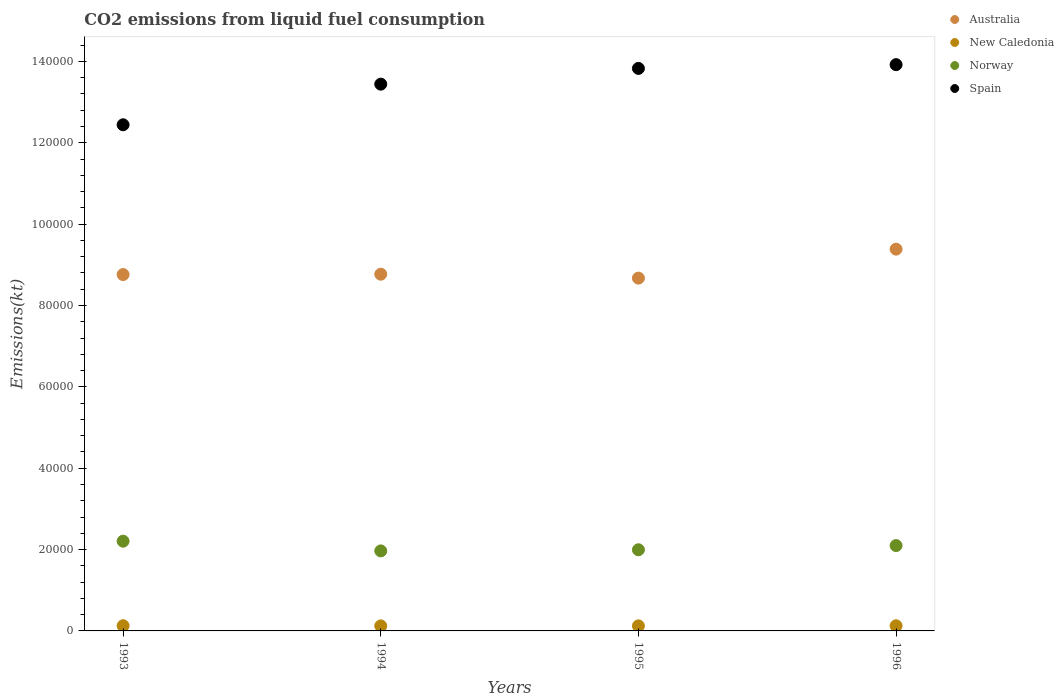Is the number of dotlines equal to the number of legend labels?
Your answer should be very brief. Yes. What is the amount of CO2 emitted in New Caledonia in 1994?
Make the answer very short. 1239.45. Across all years, what is the maximum amount of CO2 emitted in Australia?
Ensure brevity in your answer.  9.38e+04. Across all years, what is the minimum amount of CO2 emitted in New Caledonia?
Your answer should be very brief. 1239.45. In which year was the amount of CO2 emitted in Spain minimum?
Keep it short and to the point. 1993. What is the total amount of CO2 emitted in Spain in the graph?
Provide a short and direct response. 5.36e+05. What is the difference between the amount of CO2 emitted in New Caledonia in 1994 and that in 1996?
Provide a succinct answer. -29.34. What is the difference between the amount of CO2 emitted in Spain in 1995 and the amount of CO2 emitted in Norway in 1996?
Offer a terse response. 1.17e+05. What is the average amount of CO2 emitted in Spain per year?
Offer a very short reply. 1.34e+05. In the year 1993, what is the difference between the amount of CO2 emitted in Spain and amount of CO2 emitted in Australia?
Offer a terse response. 3.68e+04. What is the ratio of the amount of CO2 emitted in Spain in 1993 to that in 1996?
Make the answer very short. 0.89. Is the difference between the amount of CO2 emitted in Spain in 1993 and 1995 greater than the difference between the amount of CO2 emitted in Australia in 1993 and 1995?
Provide a succinct answer. No. What is the difference between the highest and the second highest amount of CO2 emitted in New Caledonia?
Give a very brief answer. 7.33. What is the difference between the highest and the lowest amount of CO2 emitted in Spain?
Your answer should be compact. 1.48e+04. In how many years, is the amount of CO2 emitted in Norway greater than the average amount of CO2 emitted in Norway taken over all years?
Make the answer very short. 2. Is it the case that in every year, the sum of the amount of CO2 emitted in Norway and amount of CO2 emitted in New Caledonia  is greater than the sum of amount of CO2 emitted in Australia and amount of CO2 emitted in Spain?
Keep it short and to the point. No. Is it the case that in every year, the sum of the amount of CO2 emitted in Norway and amount of CO2 emitted in New Caledonia  is greater than the amount of CO2 emitted in Australia?
Your answer should be compact. No. Is the amount of CO2 emitted in New Caledonia strictly greater than the amount of CO2 emitted in Norway over the years?
Keep it short and to the point. No. How many dotlines are there?
Offer a very short reply. 4. How many years are there in the graph?
Keep it short and to the point. 4. What is the difference between two consecutive major ticks on the Y-axis?
Keep it short and to the point. 2.00e+04. Does the graph contain any zero values?
Give a very brief answer. No. Does the graph contain grids?
Provide a succinct answer. No. How many legend labels are there?
Your answer should be compact. 4. What is the title of the graph?
Your response must be concise. CO2 emissions from liquid fuel consumption. Does "Aruba" appear as one of the legend labels in the graph?
Ensure brevity in your answer.  No. What is the label or title of the Y-axis?
Give a very brief answer. Emissions(kt). What is the Emissions(kt) of Australia in 1993?
Your answer should be very brief. 8.76e+04. What is the Emissions(kt) of New Caledonia in 1993?
Offer a very short reply. 1276.12. What is the Emissions(kt) of Norway in 1993?
Keep it short and to the point. 2.21e+04. What is the Emissions(kt) of Spain in 1993?
Your response must be concise. 1.24e+05. What is the Emissions(kt) of Australia in 1994?
Your answer should be compact. 8.77e+04. What is the Emissions(kt) of New Caledonia in 1994?
Offer a very short reply. 1239.45. What is the Emissions(kt) in Norway in 1994?
Make the answer very short. 1.97e+04. What is the Emissions(kt) in Spain in 1994?
Provide a succinct answer. 1.34e+05. What is the Emissions(kt) in Australia in 1995?
Provide a short and direct response. 8.67e+04. What is the Emissions(kt) in New Caledonia in 1995?
Give a very brief answer. 1239.45. What is the Emissions(kt) of Norway in 1995?
Keep it short and to the point. 1.99e+04. What is the Emissions(kt) of Spain in 1995?
Your answer should be compact. 1.38e+05. What is the Emissions(kt) in Australia in 1996?
Your answer should be compact. 9.38e+04. What is the Emissions(kt) of New Caledonia in 1996?
Provide a succinct answer. 1268.78. What is the Emissions(kt) of Norway in 1996?
Give a very brief answer. 2.10e+04. What is the Emissions(kt) in Spain in 1996?
Your answer should be very brief. 1.39e+05. Across all years, what is the maximum Emissions(kt) of Australia?
Give a very brief answer. 9.38e+04. Across all years, what is the maximum Emissions(kt) in New Caledonia?
Ensure brevity in your answer.  1276.12. Across all years, what is the maximum Emissions(kt) in Norway?
Your response must be concise. 2.21e+04. Across all years, what is the maximum Emissions(kt) of Spain?
Offer a very short reply. 1.39e+05. Across all years, what is the minimum Emissions(kt) of Australia?
Provide a short and direct response. 8.67e+04. Across all years, what is the minimum Emissions(kt) in New Caledonia?
Keep it short and to the point. 1239.45. Across all years, what is the minimum Emissions(kt) of Norway?
Your answer should be very brief. 1.97e+04. Across all years, what is the minimum Emissions(kt) in Spain?
Your response must be concise. 1.24e+05. What is the total Emissions(kt) in Australia in the graph?
Offer a very short reply. 3.56e+05. What is the total Emissions(kt) in New Caledonia in the graph?
Provide a short and direct response. 5023.79. What is the total Emissions(kt) of Norway in the graph?
Provide a succinct answer. 8.27e+04. What is the total Emissions(kt) of Spain in the graph?
Provide a short and direct response. 5.36e+05. What is the difference between the Emissions(kt) in Australia in 1993 and that in 1994?
Offer a very short reply. -91.67. What is the difference between the Emissions(kt) in New Caledonia in 1993 and that in 1994?
Offer a terse response. 36.67. What is the difference between the Emissions(kt) of Norway in 1993 and that in 1994?
Give a very brief answer. 2390.88. What is the difference between the Emissions(kt) in Spain in 1993 and that in 1994?
Offer a very short reply. -9988.91. What is the difference between the Emissions(kt) in Australia in 1993 and that in 1995?
Your answer should be compact. 872.75. What is the difference between the Emissions(kt) in New Caledonia in 1993 and that in 1995?
Offer a terse response. 36.67. What is the difference between the Emissions(kt) in Norway in 1993 and that in 1995?
Keep it short and to the point. 2112.19. What is the difference between the Emissions(kt) in Spain in 1993 and that in 1995?
Give a very brief answer. -1.39e+04. What is the difference between the Emissions(kt) in Australia in 1993 and that in 1996?
Give a very brief answer. -6248.57. What is the difference between the Emissions(kt) of New Caledonia in 1993 and that in 1996?
Offer a very short reply. 7.33. What is the difference between the Emissions(kt) of Norway in 1993 and that in 1996?
Keep it short and to the point. 1081.77. What is the difference between the Emissions(kt) of Spain in 1993 and that in 1996?
Your response must be concise. -1.48e+04. What is the difference between the Emissions(kt) in Australia in 1994 and that in 1995?
Provide a succinct answer. 964.42. What is the difference between the Emissions(kt) in Norway in 1994 and that in 1995?
Provide a succinct answer. -278.69. What is the difference between the Emissions(kt) in Spain in 1994 and that in 1995?
Keep it short and to the point. -3868.68. What is the difference between the Emissions(kt) in Australia in 1994 and that in 1996?
Make the answer very short. -6156.89. What is the difference between the Emissions(kt) in New Caledonia in 1994 and that in 1996?
Provide a short and direct response. -29.34. What is the difference between the Emissions(kt) of Norway in 1994 and that in 1996?
Give a very brief answer. -1309.12. What is the difference between the Emissions(kt) of Spain in 1994 and that in 1996?
Keep it short and to the point. -4796.44. What is the difference between the Emissions(kt) in Australia in 1995 and that in 1996?
Offer a terse response. -7121.31. What is the difference between the Emissions(kt) in New Caledonia in 1995 and that in 1996?
Provide a short and direct response. -29.34. What is the difference between the Emissions(kt) of Norway in 1995 and that in 1996?
Provide a succinct answer. -1030.43. What is the difference between the Emissions(kt) of Spain in 1995 and that in 1996?
Provide a short and direct response. -927.75. What is the difference between the Emissions(kt) of Australia in 1993 and the Emissions(kt) of New Caledonia in 1994?
Make the answer very short. 8.64e+04. What is the difference between the Emissions(kt) in Australia in 1993 and the Emissions(kt) in Norway in 1994?
Keep it short and to the point. 6.79e+04. What is the difference between the Emissions(kt) in Australia in 1993 and the Emissions(kt) in Spain in 1994?
Provide a short and direct response. -4.68e+04. What is the difference between the Emissions(kt) of New Caledonia in 1993 and the Emissions(kt) of Norway in 1994?
Provide a short and direct response. -1.84e+04. What is the difference between the Emissions(kt) of New Caledonia in 1993 and the Emissions(kt) of Spain in 1994?
Your answer should be very brief. -1.33e+05. What is the difference between the Emissions(kt) in Norway in 1993 and the Emissions(kt) in Spain in 1994?
Keep it short and to the point. -1.12e+05. What is the difference between the Emissions(kt) of Australia in 1993 and the Emissions(kt) of New Caledonia in 1995?
Make the answer very short. 8.64e+04. What is the difference between the Emissions(kt) of Australia in 1993 and the Emissions(kt) of Norway in 1995?
Keep it short and to the point. 6.77e+04. What is the difference between the Emissions(kt) of Australia in 1993 and the Emissions(kt) of Spain in 1995?
Keep it short and to the point. -5.07e+04. What is the difference between the Emissions(kt) of New Caledonia in 1993 and the Emissions(kt) of Norway in 1995?
Ensure brevity in your answer.  -1.87e+04. What is the difference between the Emissions(kt) of New Caledonia in 1993 and the Emissions(kt) of Spain in 1995?
Make the answer very short. -1.37e+05. What is the difference between the Emissions(kt) in Norway in 1993 and the Emissions(kt) in Spain in 1995?
Your answer should be compact. -1.16e+05. What is the difference between the Emissions(kt) of Australia in 1993 and the Emissions(kt) of New Caledonia in 1996?
Keep it short and to the point. 8.63e+04. What is the difference between the Emissions(kt) in Australia in 1993 and the Emissions(kt) in Norway in 1996?
Offer a very short reply. 6.66e+04. What is the difference between the Emissions(kt) in Australia in 1993 and the Emissions(kt) in Spain in 1996?
Give a very brief answer. -5.16e+04. What is the difference between the Emissions(kt) of New Caledonia in 1993 and the Emissions(kt) of Norway in 1996?
Ensure brevity in your answer.  -1.97e+04. What is the difference between the Emissions(kt) of New Caledonia in 1993 and the Emissions(kt) of Spain in 1996?
Ensure brevity in your answer.  -1.38e+05. What is the difference between the Emissions(kt) in Norway in 1993 and the Emissions(kt) in Spain in 1996?
Your response must be concise. -1.17e+05. What is the difference between the Emissions(kt) of Australia in 1994 and the Emissions(kt) of New Caledonia in 1995?
Ensure brevity in your answer.  8.65e+04. What is the difference between the Emissions(kt) of Australia in 1994 and the Emissions(kt) of Norway in 1995?
Offer a very short reply. 6.77e+04. What is the difference between the Emissions(kt) in Australia in 1994 and the Emissions(kt) in Spain in 1995?
Give a very brief answer. -5.06e+04. What is the difference between the Emissions(kt) of New Caledonia in 1994 and the Emissions(kt) of Norway in 1995?
Keep it short and to the point. -1.87e+04. What is the difference between the Emissions(kt) in New Caledonia in 1994 and the Emissions(kt) in Spain in 1995?
Your answer should be very brief. -1.37e+05. What is the difference between the Emissions(kt) of Norway in 1994 and the Emissions(kt) of Spain in 1995?
Offer a very short reply. -1.19e+05. What is the difference between the Emissions(kt) of Australia in 1994 and the Emissions(kt) of New Caledonia in 1996?
Ensure brevity in your answer.  8.64e+04. What is the difference between the Emissions(kt) of Australia in 1994 and the Emissions(kt) of Norway in 1996?
Your answer should be compact. 6.67e+04. What is the difference between the Emissions(kt) in Australia in 1994 and the Emissions(kt) in Spain in 1996?
Ensure brevity in your answer.  -5.15e+04. What is the difference between the Emissions(kt) of New Caledonia in 1994 and the Emissions(kt) of Norway in 1996?
Ensure brevity in your answer.  -1.97e+04. What is the difference between the Emissions(kt) in New Caledonia in 1994 and the Emissions(kt) in Spain in 1996?
Your answer should be compact. -1.38e+05. What is the difference between the Emissions(kt) of Norway in 1994 and the Emissions(kt) of Spain in 1996?
Ensure brevity in your answer.  -1.20e+05. What is the difference between the Emissions(kt) in Australia in 1995 and the Emissions(kt) in New Caledonia in 1996?
Ensure brevity in your answer.  8.55e+04. What is the difference between the Emissions(kt) in Australia in 1995 and the Emissions(kt) in Norway in 1996?
Your response must be concise. 6.57e+04. What is the difference between the Emissions(kt) of Australia in 1995 and the Emissions(kt) of Spain in 1996?
Make the answer very short. -5.25e+04. What is the difference between the Emissions(kt) in New Caledonia in 1995 and the Emissions(kt) in Norway in 1996?
Provide a succinct answer. -1.97e+04. What is the difference between the Emissions(kt) in New Caledonia in 1995 and the Emissions(kt) in Spain in 1996?
Provide a short and direct response. -1.38e+05. What is the difference between the Emissions(kt) of Norway in 1995 and the Emissions(kt) of Spain in 1996?
Offer a very short reply. -1.19e+05. What is the average Emissions(kt) in Australia per year?
Your answer should be very brief. 8.90e+04. What is the average Emissions(kt) of New Caledonia per year?
Provide a succinct answer. 1255.95. What is the average Emissions(kt) in Norway per year?
Your response must be concise. 2.07e+04. What is the average Emissions(kt) of Spain per year?
Provide a succinct answer. 1.34e+05. In the year 1993, what is the difference between the Emissions(kt) of Australia and Emissions(kt) of New Caledonia?
Your answer should be very brief. 8.63e+04. In the year 1993, what is the difference between the Emissions(kt) in Australia and Emissions(kt) in Norway?
Your answer should be compact. 6.55e+04. In the year 1993, what is the difference between the Emissions(kt) in Australia and Emissions(kt) in Spain?
Give a very brief answer. -3.68e+04. In the year 1993, what is the difference between the Emissions(kt) of New Caledonia and Emissions(kt) of Norway?
Ensure brevity in your answer.  -2.08e+04. In the year 1993, what is the difference between the Emissions(kt) in New Caledonia and Emissions(kt) in Spain?
Make the answer very short. -1.23e+05. In the year 1993, what is the difference between the Emissions(kt) in Norway and Emissions(kt) in Spain?
Keep it short and to the point. -1.02e+05. In the year 1994, what is the difference between the Emissions(kt) of Australia and Emissions(kt) of New Caledonia?
Offer a very short reply. 8.65e+04. In the year 1994, what is the difference between the Emissions(kt) in Australia and Emissions(kt) in Norway?
Provide a short and direct response. 6.80e+04. In the year 1994, what is the difference between the Emissions(kt) in Australia and Emissions(kt) in Spain?
Make the answer very short. -4.67e+04. In the year 1994, what is the difference between the Emissions(kt) of New Caledonia and Emissions(kt) of Norway?
Your response must be concise. -1.84e+04. In the year 1994, what is the difference between the Emissions(kt) of New Caledonia and Emissions(kt) of Spain?
Provide a succinct answer. -1.33e+05. In the year 1994, what is the difference between the Emissions(kt) of Norway and Emissions(kt) of Spain?
Keep it short and to the point. -1.15e+05. In the year 1995, what is the difference between the Emissions(kt) of Australia and Emissions(kt) of New Caledonia?
Your answer should be compact. 8.55e+04. In the year 1995, what is the difference between the Emissions(kt) in Australia and Emissions(kt) in Norway?
Keep it short and to the point. 6.68e+04. In the year 1995, what is the difference between the Emissions(kt) of Australia and Emissions(kt) of Spain?
Your answer should be very brief. -5.16e+04. In the year 1995, what is the difference between the Emissions(kt) of New Caledonia and Emissions(kt) of Norway?
Your response must be concise. -1.87e+04. In the year 1995, what is the difference between the Emissions(kt) of New Caledonia and Emissions(kt) of Spain?
Provide a succinct answer. -1.37e+05. In the year 1995, what is the difference between the Emissions(kt) of Norway and Emissions(kt) of Spain?
Your response must be concise. -1.18e+05. In the year 1996, what is the difference between the Emissions(kt) in Australia and Emissions(kt) in New Caledonia?
Offer a terse response. 9.26e+04. In the year 1996, what is the difference between the Emissions(kt) in Australia and Emissions(kt) in Norway?
Your answer should be compact. 7.29e+04. In the year 1996, what is the difference between the Emissions(kt) in Australia and Emissions(kt) in Spain?
Your answer should be very brief. -4.54e+04. In the year 1996, what is the difference between the Emissions(kt) of New Caledonia and Emissions(kt) of Norway?
Your answer should be very brief. -1.97e+04. In the year 1996, what is the difference between the Emissions(kt) in New Caledonia and Emissions(kt) in Spain?
Provide a succinct answer. -1.38e+05. In the year 1996, what is the difference between the Emissions(kt) of Norway and Emissions(kt) of Spain?
Offer a very short reply. -1.18e+05. What is the ratio of the Emissions(kt) of Australia in 1993 to that in 1994?
Keep it short and to the point. 1. What is the ratio of the Emissions(kt) of New Caledonia in 1993 to that in 1994?
Provide a succinct answer. 1.03. What is the ratio of the Emissions(kt) in Norway in 1993 to that in 1994?
Your response must be concise. 1.12. What is the ratio of the Emissions(kt) of Spain in 1993 to that in 1994?
Offer a very short reply. 0.93. What is the ratio of the Emissions(kt) of New Caledonia in 1993 to that in 1995?
Make the answer very short. 1.03. What is the ratio of the Emissions(kt) in Norway in 1993 to that in 1995?
Offer a very short reply. 1.11. What is the ratio of the Emissions(kt) in Spain in 1993 to that in 1995?
Offer a terse response. 0.9. What is the ratio of the Emissions(kt) in Australia in 1993 to that in 1996?
Offer a terse response. 0.93. What is the ratio of the Emissions(kt) of Norway in 1993 to that in 1996?
Ensure brevity in your answer.  1.05. What is the ratio of the Emissions(kt) in Spain in 1993 to that in 1996?
Give a very brief answer. 0.89. What is the ratio of the Emissions(kt) of Australia in 1994 to that in 1995?
Offer a very short reply. 1.01. What is the ratio of the Emissions(kt) in Australia in 1994 to that in 1996?
Keep it short and to the point. 0.93. What is the ratio of the Emissions(kt) in New Caledonia in 1994 to that in 1996?
Make the answer very short. 0.98. What is the ratio of the Emissions(kt) in Norway in 1994 to that in 1996?
Keep it short and to the point. 0.94. What is the ratio of the Emissions(kt) of Spain in 1994 to that in 1996?
Provide a short and direct response. 0.97. What is the ratio of the Emissions(kt) of Australia in 1995 to that in 1996?
Your response must be concise. 0.92. What is the ratio of the Emissions(kt) in New Caledonia in 1995 to that in 1996?
Provide a short and direct response. 0.98. What is the ratio of the Emissions(kt) in Norway in 1995 to that in 1996?
Offer a terse response. 0.95. What is the difference between the highest and the second highest Emissions(kt) in Australia?
Your response must be concise. 6156.89. What is the difference between the highest and the second highest Emissions(kt) in New Caledonia?
Provide a succinct answer. 7.33. What is the difference between the highest and the second highest Emissions(kt) of Norway?
Your response must be concise. 1081.77. What is the difference between the highest and the second highest Emissions(kt) of Spain?
Keep it short and to the point. 927.75. What is the difference between the highest and the lowest Emissions(kt) of Australia?
Offer a very short reply. 7121.31. What is the difference between the highest and the lowest Emissions(kt) in New Caledonia?
Provide a short and direct response. 36.67. What is the difference between the highest and the lowest Emissions(kt) of Norway?
Your response must be concise. 2390.88. What is the difference between the highest and the lowest Emissions(kt) of Spain?
Your answer should be compact. 1.48e+04. 